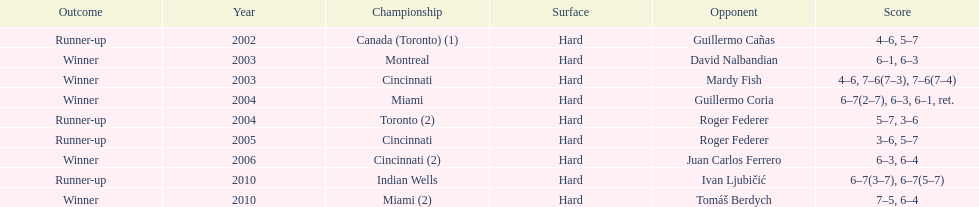Could you help me parse every detail presented in this table? {'header': ['Outcome', 'Year', 'Championship', 'Surface', 'Opponent', 'Score'], 'rows': [['Runner-up', '2002', 'Canada (Toronto) (1)', 'Hard', 'Guillermo Cañas', '4–6, 5–7'], ['Winner', '2003', 'Montreal', 'Hard', 'David Nalbandian', '6–1, 6–3'], ['Winner', '2003', 'Cincinnati', 'Hard', 'Mardy Fish', '4–6, 7–6(7–3), 7–6(7–4)'], ['Winner', '2004', 'Miami', 'Hard', 'Guillermo Coria', '6–7(2–7), 6–3, 6–1, ret.'], ['Runner-up', '2004', 'Toronto (2)', 'Hard', 'Roger Federer', '5–7, 3–6'], ['Runner-up', '2005', 'Cincinnati', 'Hard', 'Roger Federer', '3–6, 5–7'], ['Winner', '2006', 'Cincinnati (2)', 'Hard', 'Juan Carlos Ferrero', '6–3, 6–4'], ['Runner-up', '2010', 'Indian Wells', 'Hard', 'Ivan Ljubičić', '6–7(3–7), 6–7(5–7)'], ['Winner', '2010', 'Miami (2)', 'Hard', 'Tomáš Berdych', '7–5, 6–4']]} What is the number of times roger federer finished as a runner-up? 2. 